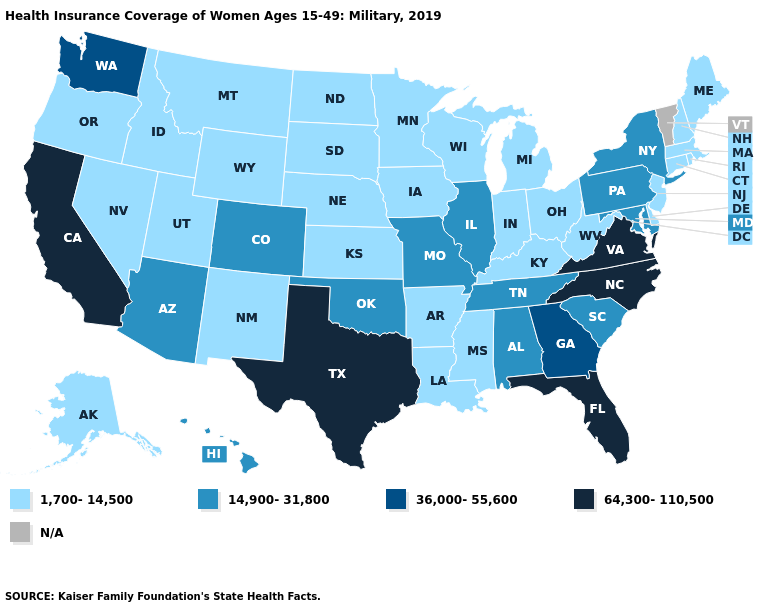Which states hav the highest value in the West?
Write a very short answer. California. Does Minnesota have the highest value in the USA?
Write a very short answer. No. What is the highest value in the MidWest ?
Short answer required. 14,900-31,800. What is the value of Missouri?
Give a very brief answer. 14,900-31,800. Among the states that border New Mexico , does Texas have the highest value?
Short answer required. Yes. Is the legend a continuous bar?
Write a very short answer. No. Which states have the highest value in the USA?
Concise answer only. California, Florida, North Carolina, Texas, Virginia. What is the lowest value in the MidWest?
Quick response, please. 1,700-14,500. Name the states that have a value in the range N/A?
Be succinct. Vermont. Name the states that have a value in the range N/A?
Keep it brief. Vermont. What is the lowest value in the MidWest?
Be succinct. 1,700-14,500. How many symbols are there in the legend?
Be succinct. 5. What is the value of New Jersey?
Short answer required. 1,700-14,500. 